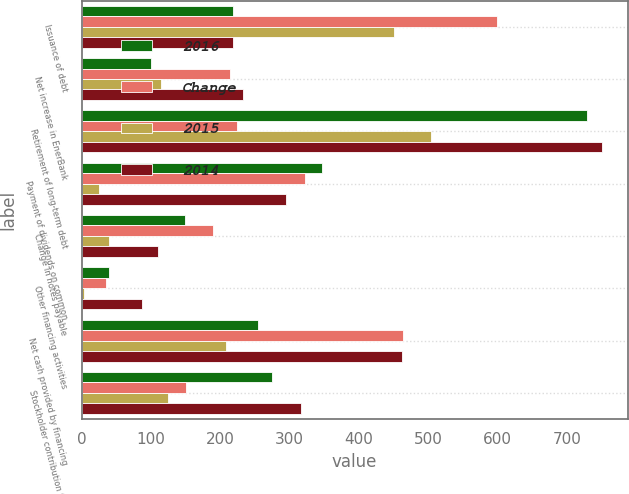<chart> <loc_0><loc_0><loc_500><loc_500><stacked_bar_chart><ecel><fcel>Issuance of debt<fcel>Net increase in EnerBank<fcel>Retirement of long-term debt<fcel>Payment of dividends on common<fcel>Change in notes payable<fcel>Other financing activities<fcel>Net cash provided by financing<fcel>Stockholder contribution from<nl><fcel>2016<fcel>219<fcel>100<fcel>728<fcel>347<fcel>149<fcel>40<fcel>255<fcel>275<nl><fcel>Change<fcel>599<fcel>214<fcel>224<fcel>322<fcel>189<fcel>36<fcel>463<fcel>150<nl><fcel>2015<fcel>450<fcel>114<fcel>504<fcel>25<fcel>40<fcel>4<fcel>208<fcel>125<nl><fcel>2014<fcel>219<fcel>233<fcel>750<fcel>295<fcel>110<fcel>87<fcel>462<fcel>317<nl></chart> 